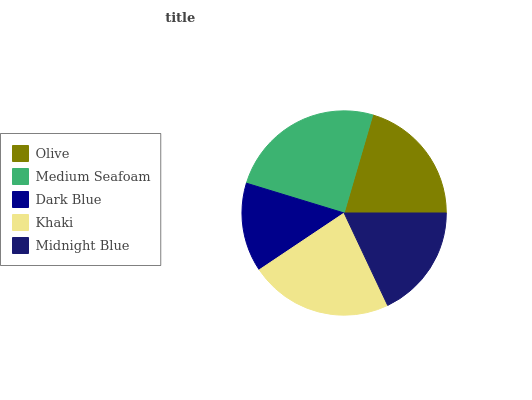Is Dark Blue the minimum?
Answer yes or no. Yes. Is Medium Seafoam the maximum?
Answer yes or no. Yes. Is Medium Seafoam the minimum?
Answer yes or no. No. Is Dark Blue the maximum?
Answer yes or no. No. Is Medium Seafoam greater than Dark Blue?
Answer yes or no. Yes. Is Dark Blue less than Medium Seafoam?
Answer yes or no. Yes. Is Dark Blue greater than Medium Seafoam?
Answer yes or no. No. Is Medium Seafoam less than Dark Blue?
Answer yes or no. No. Is Olive the high median?
Answer yes or no. Yes. Is Olive the low median?
Answer yes or no. Yes. Is Midnight Blue the high median?
Answer yes or no. No. Is Medium Seafoam the low median?
Answer yes or no. No. 